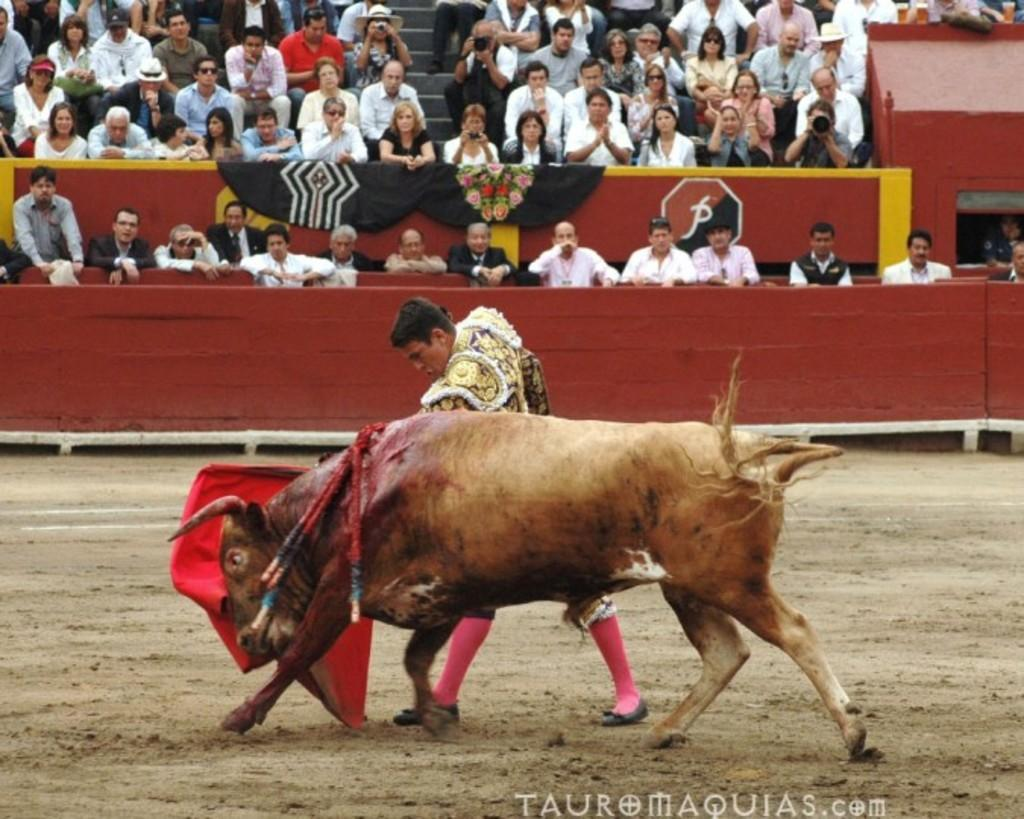What is the person in the image doing? The person is standing on the ground and holding a bull. What can be seen in the background of the image? There are people sitting in a stadium. What are the people in the stadium doing? The people are watching a show. What type of yam is being used as a prop in the show? There is no yam present in the image, and it is not mentioned that a yam is being used as a prop in the show. 